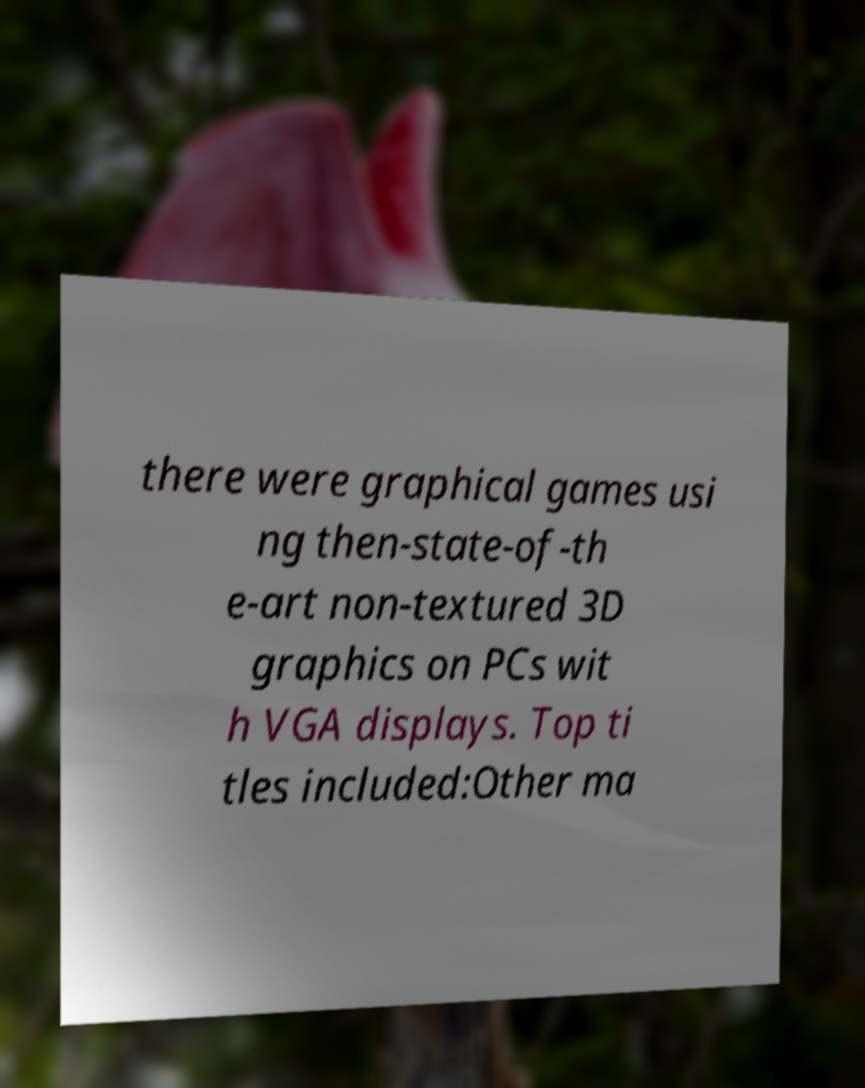Please identify and transcribe the text found in this image. there were graphical games usi ng then-state-of-th e-art non-textured 3D graphics on PCs wit h VGA displays. Top ti tles included:Other ma 